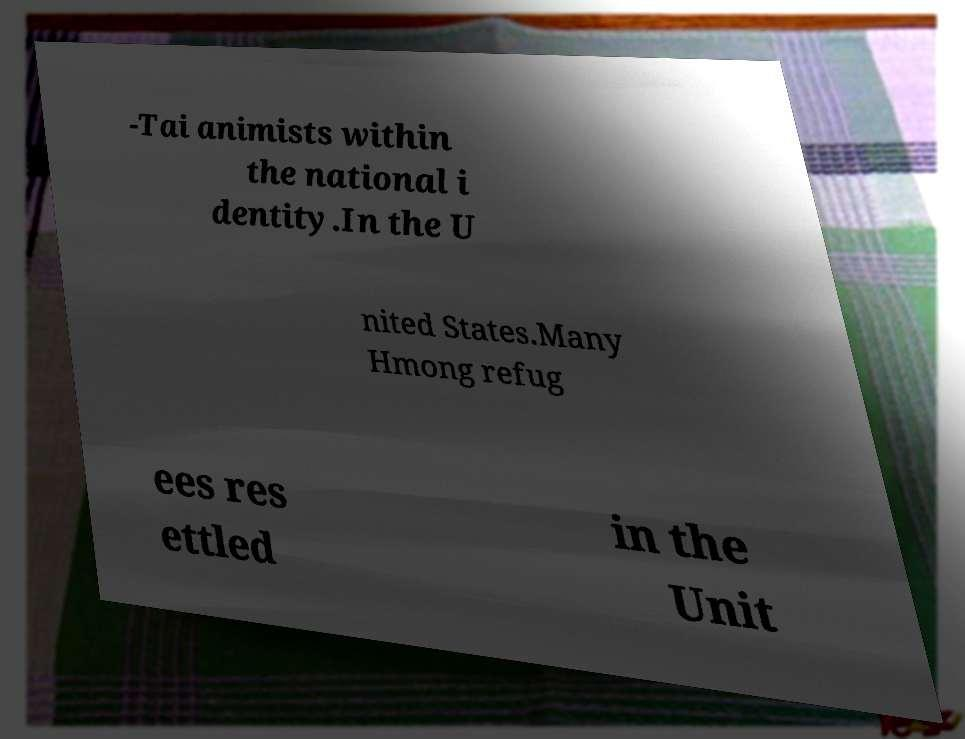Could you extract and type out the text from this image? -Tai animists within the national i dentity.In the U nited States.Many Hmong refug ees res ettled in the Unit 